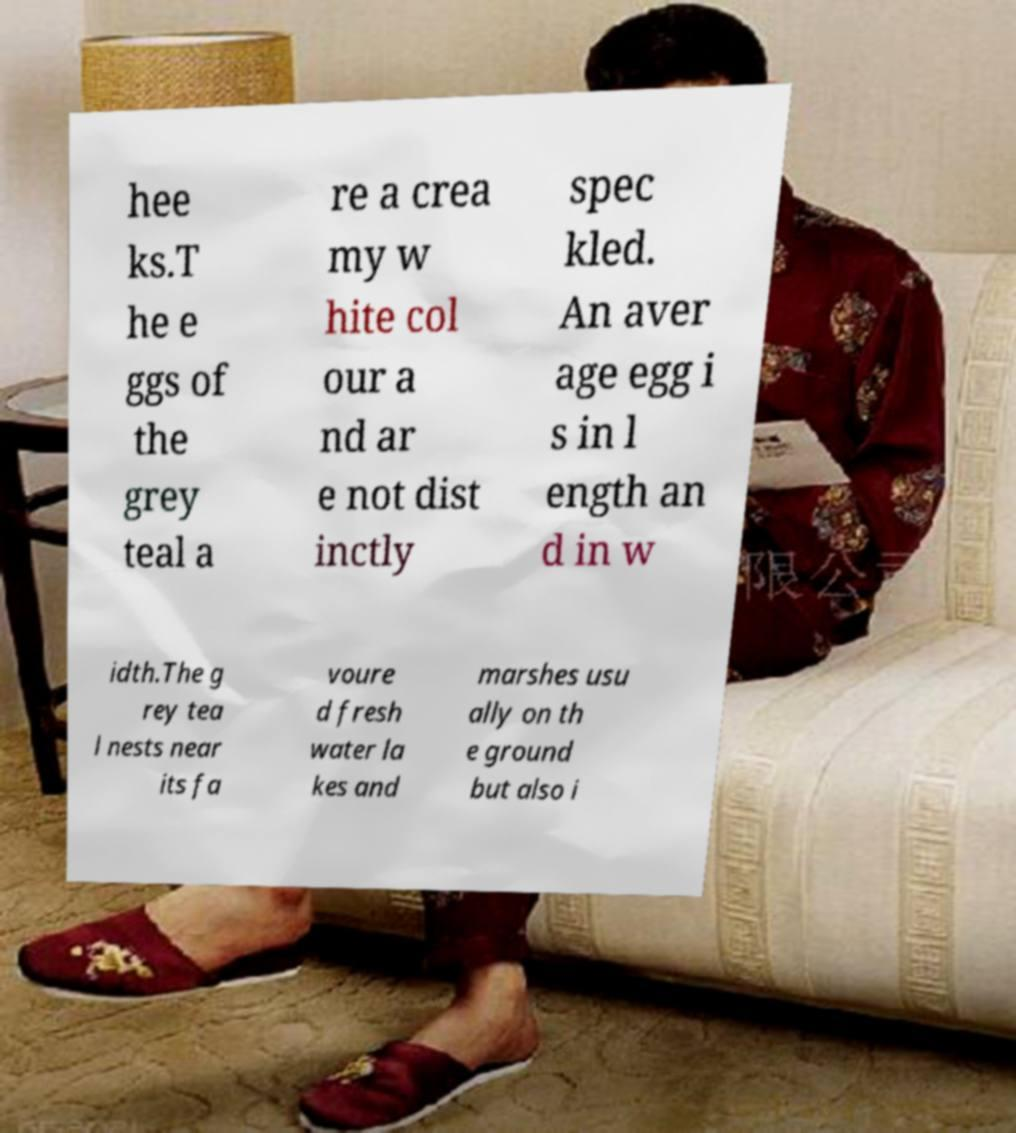Can you accurately transcribe the text from the provided image for me? hee ks.T he e ggs of the grey teal a re a crea my w hite col our a nd ar e not dist inctly spec kled. An aver age egg i s in l ength an d in w idth.The g rey tea l nests near its fa voure d fresh water la kes and marshes usu ally on th e ground but also i 